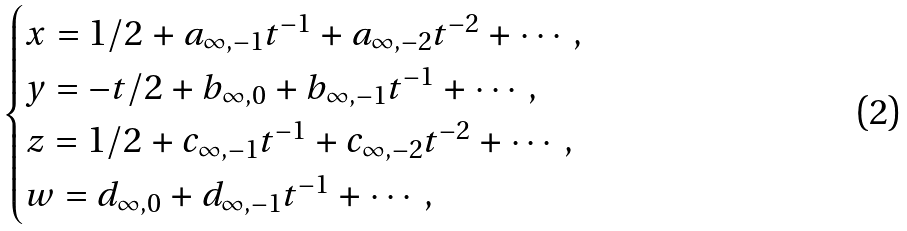<formula> <loc_0><loc_0><loc_500><loc_500>\begin{cases} x = 1 / 2 + a _ { \infty , - 1 } t ^ { - 1 } + a _ { \infty , - 2 } t ^ { - 2 } + \cdots , \\ y = - t / 2 + b _ { \infty , 0 } + b _ { \infty , - 1 } t ^ { - 1 } + \cdots , \\ z = 1 / 2 + c _ { \infty , - 1 } t ^ { - 1 } + c _ { \infty , - 2 } t ^ { - 2 } + \cdots , \\ w = d _ { \infty , 0 } + d _ { \infty , - 1 } t ^ { - 1 } + \cdots , \end{cases}</formula> 